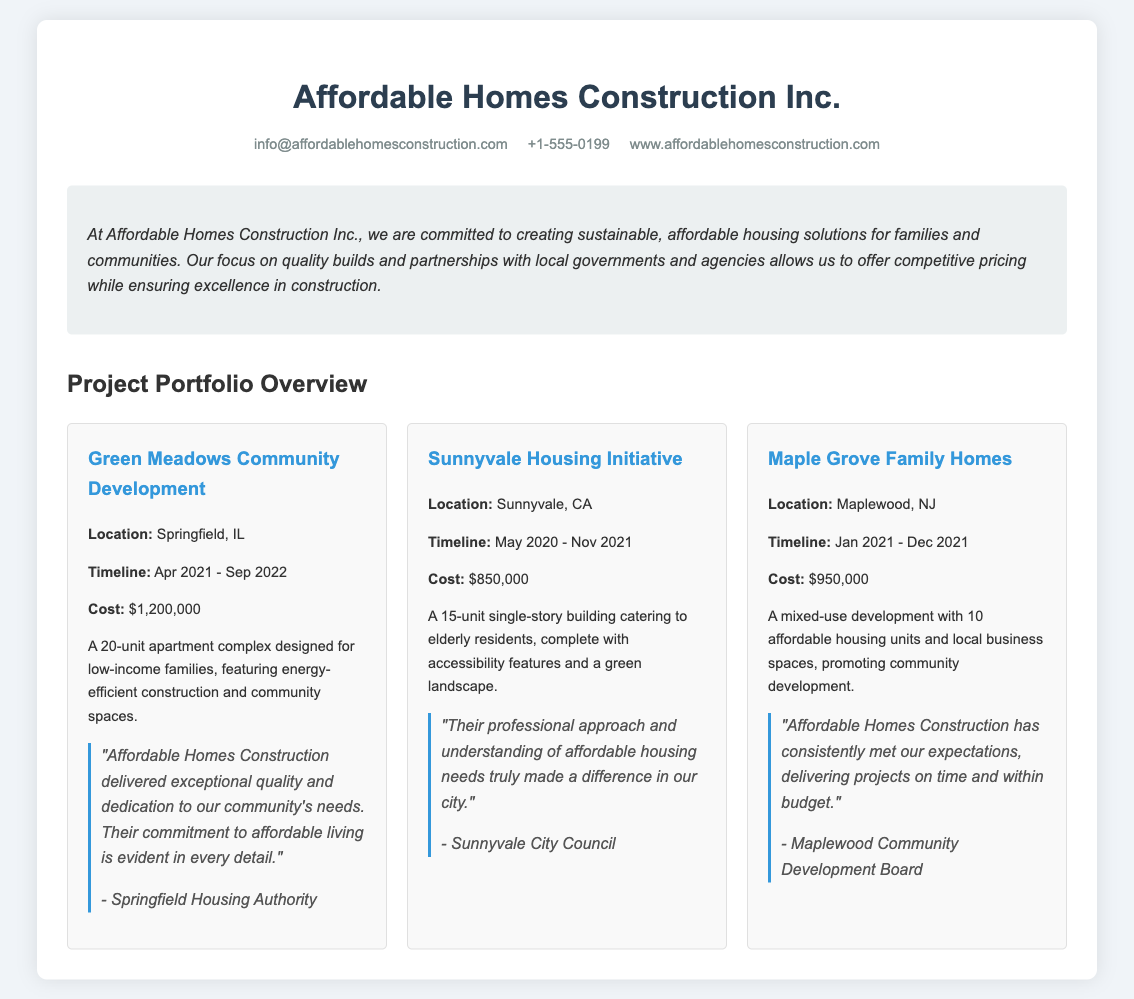what is the location of Green Meadows Community Development? Green Meadows Community Development is located in Springfield, IL as stated in the project details.
Answer: Springfield, IL what is the timeline for the Sunnyvale Housing Initiative? The timeline for the Sunnyvale Housing Initiative is mentioned as May 2020 - Nov 2021.
Answer: May 2020 - Nov 2021 what was the cost of the Maple Grove Family Homes project? The cost of the Maple Grove Family Homes project is specified as $950,000.
Answer: $950,000 how many total units are built in the Green Meadows Community Development? The number of units built in the Green Meadows Community Development is given as 20 units.
Answer: 20 units which project is designed for elderly residents? The project designed for elderly residents is listed as Sunnyvale Housing Initiative in the document.
Answer: Sunnyvale Housing Initiative who provided a testimonial for the Green Meadows Community Development project? The testimonial for the Green Meadows Community Development project was given by the Springfield Housing Authority.
Answer: Springfield Housing Authority what is the main focus of Affordable Homes Construction Inc. according to the summary? The main focus of Affordable Homes Construction Inc. according to the summary is creating sustainable, affordable housing solutions.
Answer: sustainable, affordable housing solutions how many projects are included in this project portfolio overview? The document lists a total of three completed projects as part of the portfolio overview.
Answer: three what type of development is Maple Grove Family Homes? The Maple Grove Family Homes is categorized as a mixed-use development in the project description.
Answer: mixed-use development 